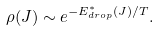Convert formula to latex. <formula><loc_0><loc_0><loc_500><loc_500>\rho ( J ) \sim e ^ { - { E _ { d r o p } ^ { * } ( J ) } / { T } } .</formula> 